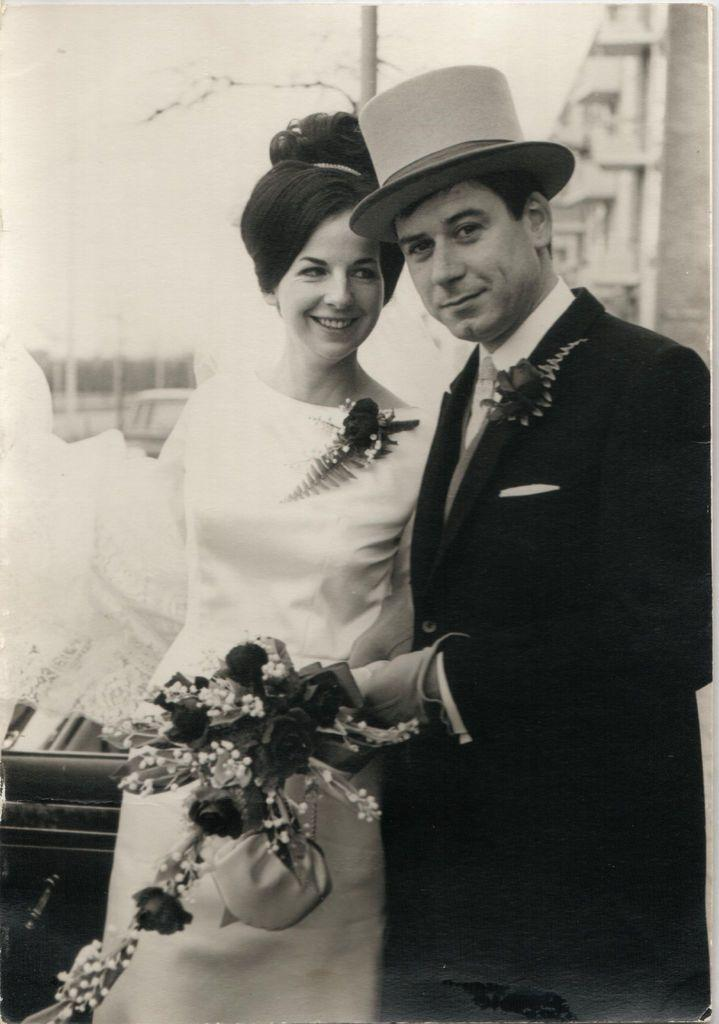What is the color scheme of the image? The image is black and white. What is happening in the middle of the image? There is a couple in the middle of the image. What are they holding? The couple is holding a bouquet. What can be seen in the background of the image? There is a building in the background of the image. What is the man wearing? The man is wearing a hat. What type of throne is the couple sitting on in the image? There is no throne present in the image; it features a couple holding a bouquet in a black and white setting. How much salt is visible on the table in the image? There is no salt visible in the image; it only shows a couple holding a bouquet, a building in the background, and a man wearing a hat. 